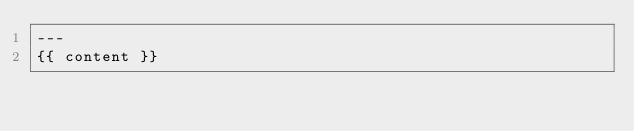Convert code to text. <code><loc_0><loc_0><loc_500><loc_500><_HTML_>---
{{ content }}
</code> 